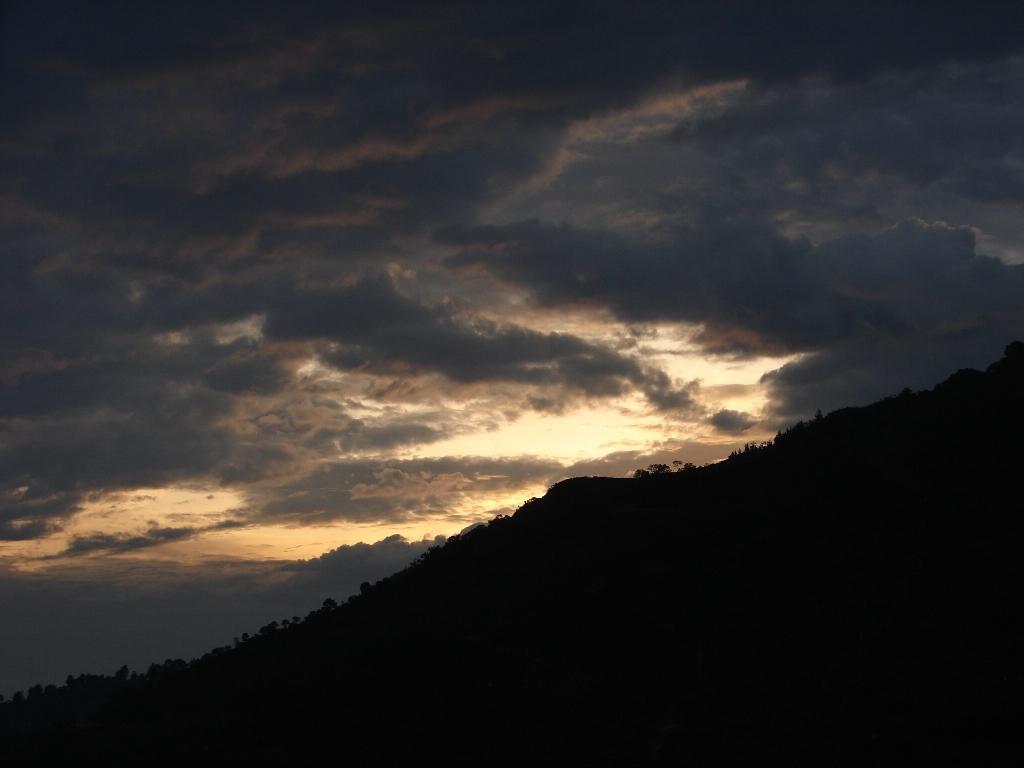Can you describe this image briefly? In this picture we can see few trees and clouds. 